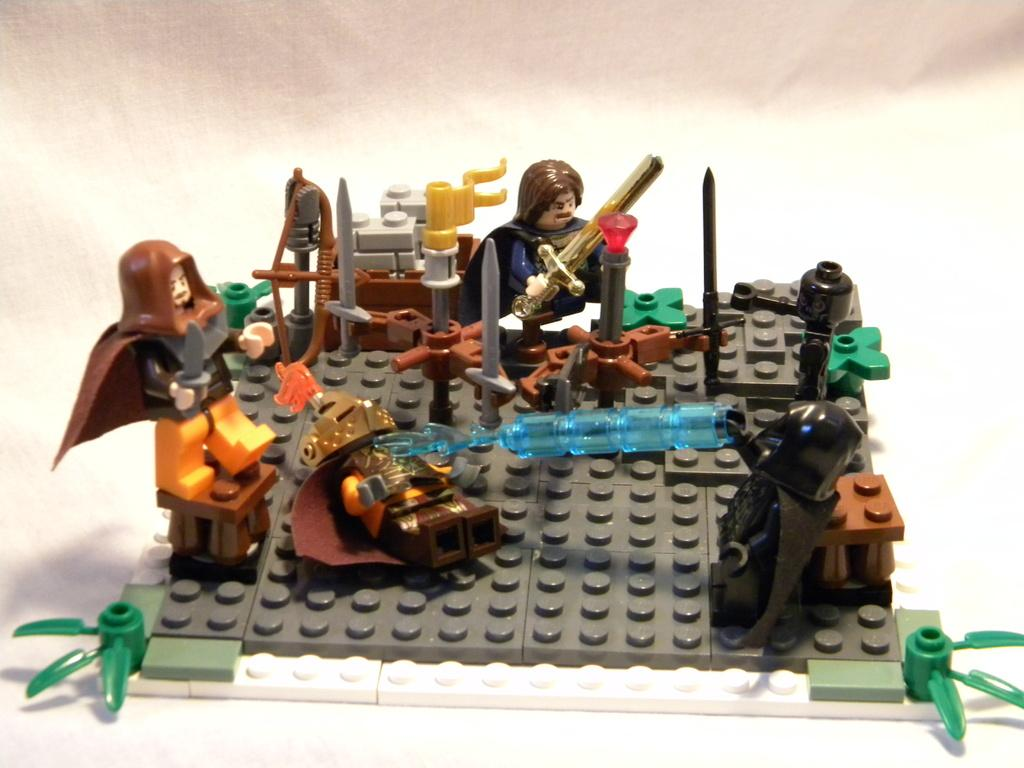What objects are present in the image? There are toys in the image. Where are the toys placed? The toys are on a building block. What is the color of the surface beneath the building block? The building block is on a white surface. What type of stocking is hanging from the building block in the image? There is no stocking present in the image. Can you see any bones or donkeys in the image? No, there are no bones or donkeys present in the image. 